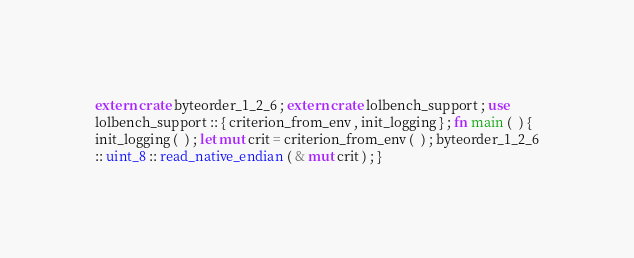Convert code to text. <code><loc_0><loc_0><loc_500><loc_500><_Rust_>extern crate byteorder_1_2_6 ; extern crate lolbench_support ; use
lolbench_support :: { criterion_from_env , init_logging } ; fn main (  ) {
init_logging (  ) ; let mut crit = criterion_from_env (  ) ; byteorder_1_2_6
:: uint_8 :: read_native_endian ( & mut crit ) ; }</code> 